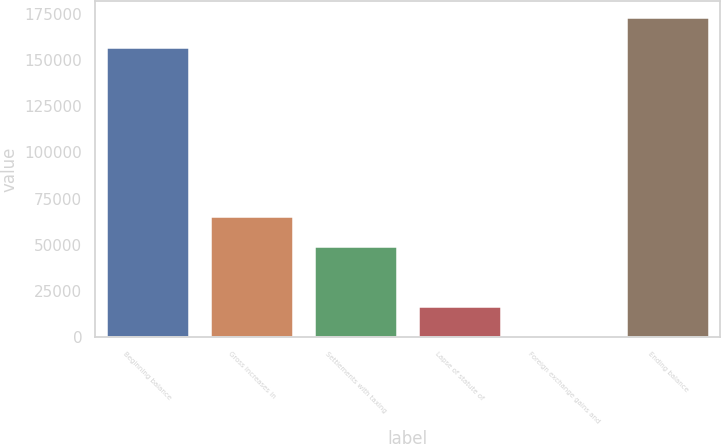Convert chart to OTSL. <chart><loc_0><loc_0><loc_500><loc_500><bar_chart><fcel>Beginning balance<fcel>Gross increases in<fcel>Settlements with taxing<fcel>Lapse of statute of<fcel>Foreign exchange gains and<fcel>Ending balance<nl><fcel>156925<fcel>65778.2<fcel>49473.4<fcel>16863.8<fcel>559<fcel>173230<nl></chart> 